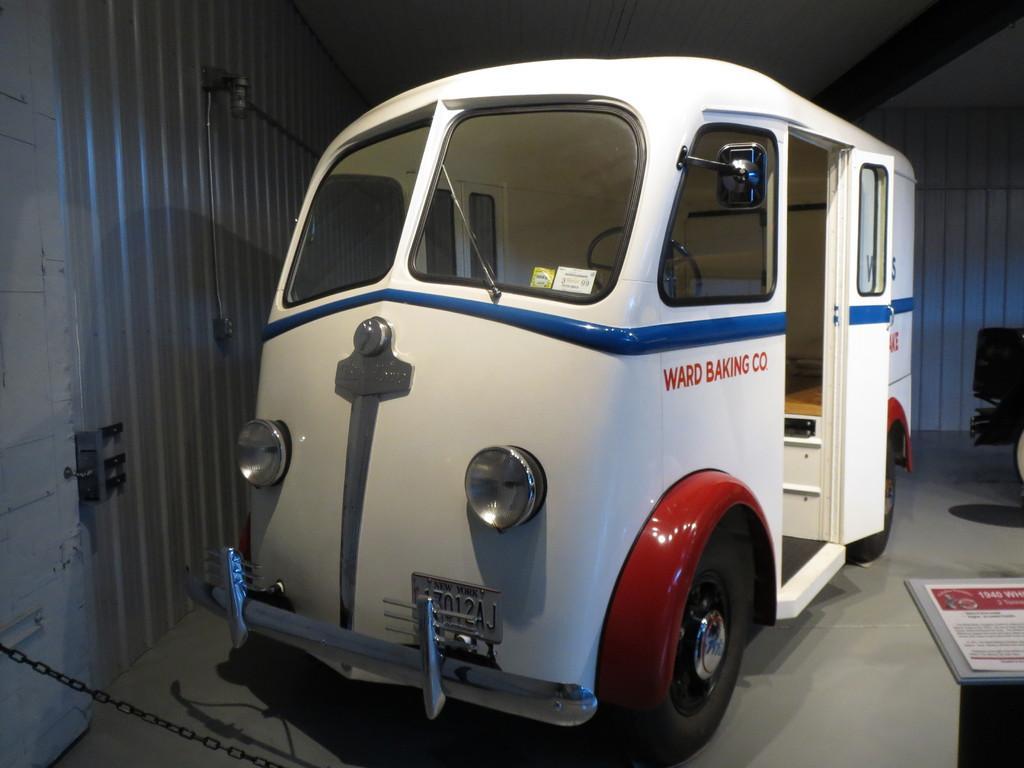Please provide a concise description of this image. In this image we can see a vehicle parked on the ground. In the background we can see a door and a chain. 